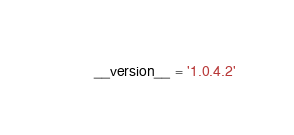<code> <loc_0><loc_0><loc_500><loc_500><_Python_>__version__ = '1.0.4.2'
</code> 